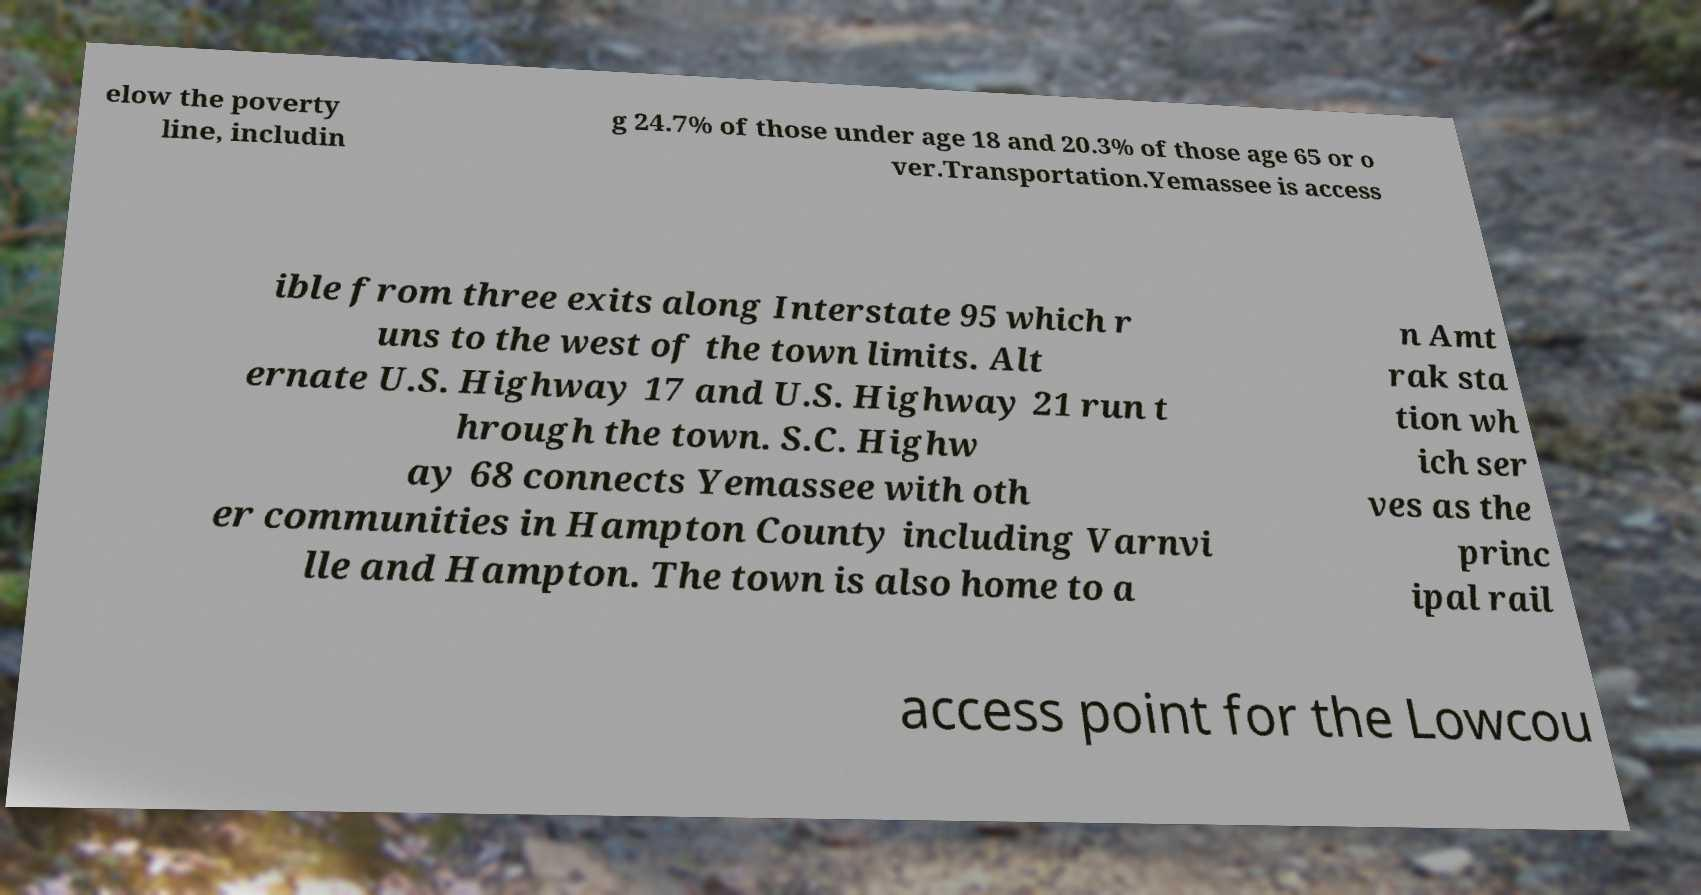What messages or text are displayed in this image? I need them in a readable, typed format. elow the poverty line, includin g 24.7% of those under age 18 and 20.3% of those age 65 or o ver.Transportation.Yemassee is access ible from three exits along Interstate 95 which r uns to the west of the town limits. Alt ernate U.S. Highway 17 and U.S. Highway 21 run t hrough the town. S.C. Highw ay 68 connects Yemassee with oth er communities in Hampton County including Varnvi lle and Hampton. The town is also home to a n Amt rak sta tion wh ich ser ves as the princ ipal rail access point for the Lowcou 